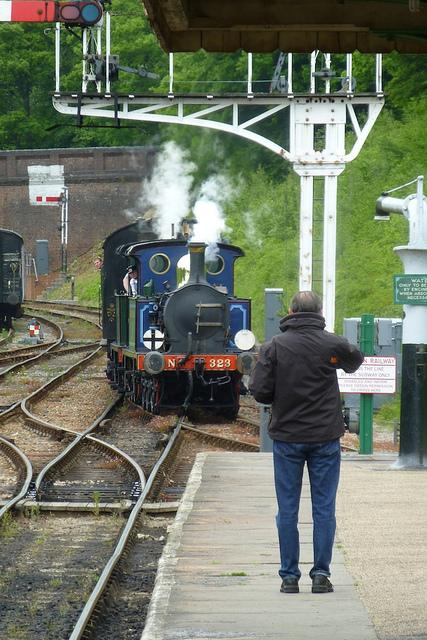Why are the people travelling on the train? Please explain your reasoning. touring. People are standing on a train platform. 